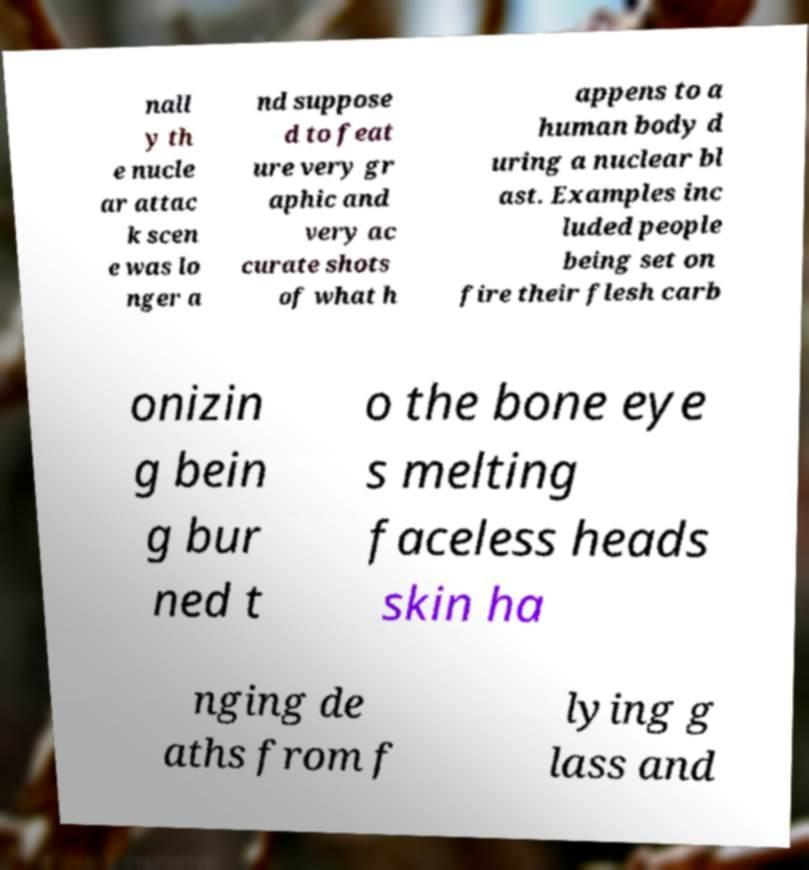Could you assist in decoding the text presented in this image and type it out clearly? nall y th e nucle ar attac k scen e was lo nger a nd suppose d to feat ure very gr aphic and very ac curate shots of what h appens to a human body d uring a nuclear bl ast. Examples inc luded people being set on fire their flesh carb onizin g bein g bur ned t o the bone eye s melting faceless heads skin ha nging de aths from f lying g lass and 